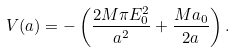Convert formula to latex. <formula><loc_0><loc_0><loc_500><loc_500>V ( a ) = - \left ( \frac { 2 M \pi E _ { 0 } ^ { 2 } } { a ^ { 2 } } + \frac { M a _ { 0 } } { 2 a } \right ) .</formula> 